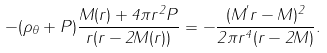Convert formula to latex. <formula><loc_0><loc_0><loc_500><loc_500>- ( \rho _ { \theta } + P ) \frac { M ( r ) + 4 \pi r ^ { 2 } P } { r ( r - 2 M ( r ) ) } = - \frac { ( M ^ { ^ { \prime } } r - M ) ^ { 2 } } { 2 \pi r ^ { 4 } ( r - 2 M ) } .</formula> 